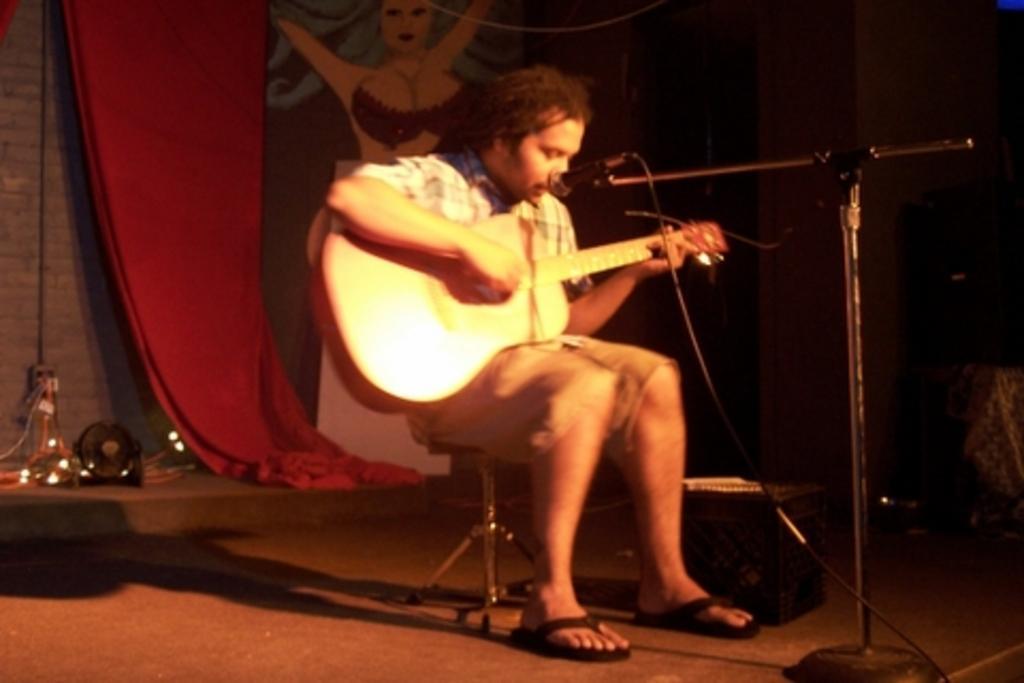Please provide a concise description of this image. This picture is clicked in a musical concert. Man in the middle of the picture sitting on chair is holding guitar in his hands and playing it. In front of him, we see a microphone and he is singing on it. Beside him, we see a sheet which is red in color. 